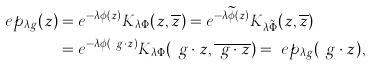<formula> <loc_0><loc_0><loc_500><loc_500>\ e p _ { \lambda g } ( z ) & = e ^ { - \lambda \phi ( z ) } K _ { \lambda \Phi } ( z , \overline { z } ) = e ^ { - \lambda \widetilde { \phi } ( z ) } K _ { \lambda \tilde { \Phi } } ( z , \overline { z } ) \\ & = e ^ { - \lambda \phi ( \ g \cdot z ) } K _ { \lambda \Phi } ( \ g \cdot z , \overline { \ g \cdot z } ) = \ e p _ { \lambda g } ( \ g \cdot z ) ,</formula> 